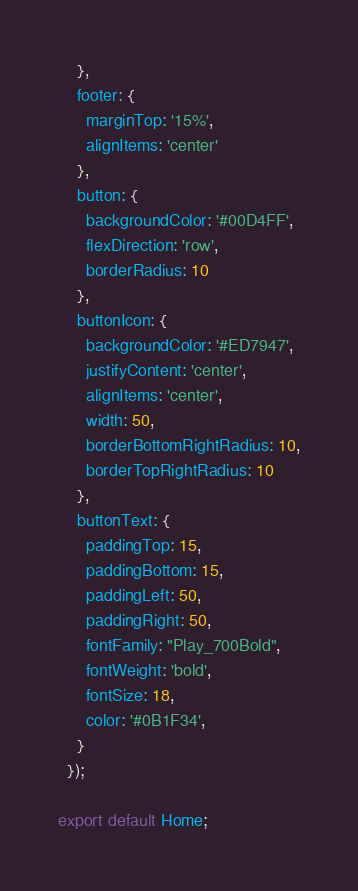<code> <loc_0><loc_0><loc_500><loc_500><_TypeScript_>    },
    footer: {
      marginTop: '15%',
      alignItems: 'center'
    },
    button: {
      backgroundColor: '#00D4FF',
      flexDirection: 'row',
      borderRadius: 10
    },
    buttonIcon: {
      backgroundColor: '#ED7947',
      justifyContent: 'center',
      alignItems: 'center',
      width: 50,
      borderBottomRightRadius: 10,
      borderTopRightRadius: 10
    },
    buttonText: {
      paddingTop: 15,
      paddingBottom: 15,
      paddingLeft: 50,
      paddingRight: 50,
      fontFamily: "Play_700Bold",
      fontWeight: 'bold',
      fontSize: 18,
      color: '#0B1F34',
    }
  });

export default Home;</code> 